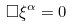<formula> <loc_0><loc_0><loc_500><loc_500>\Box \xi ^ { \alpha } = 0 \,</formula> 